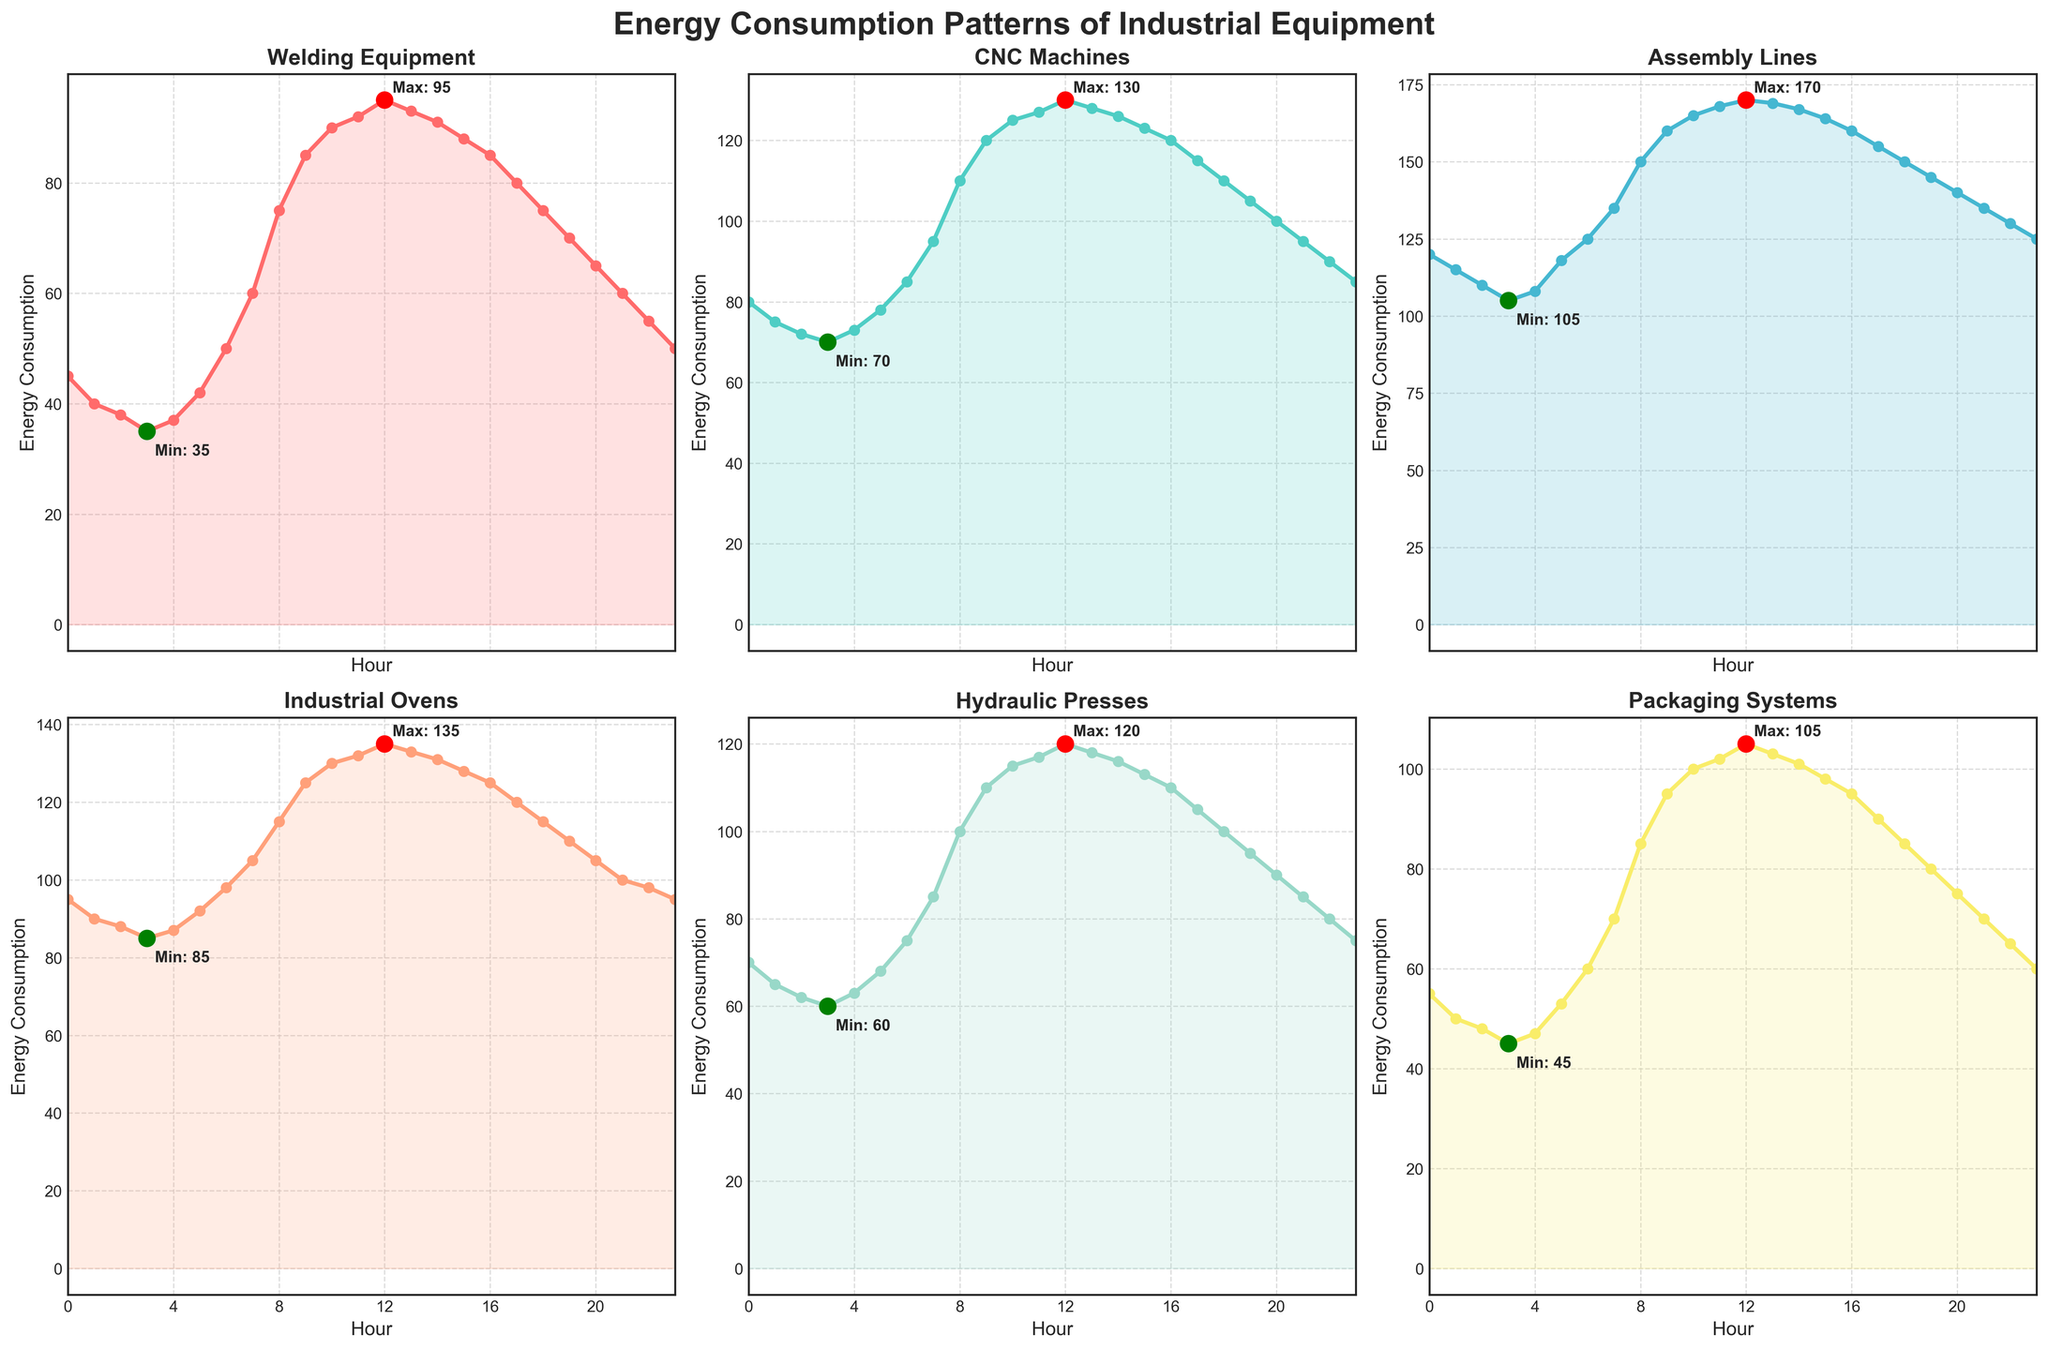What is the maximum energy consumption recorded for Welding Equipment and when does it occur? From the subplot for Welding Equipment, the red highlight indicates the maximum point. Checking the annotated label, the highest value is 95 at hour 12
Answer: 95 at hour 12 Which equipment type consumes the most energy at hour 10? At hour 10, we need to compare the energy consumption across all subplots. Assembly Lines has the tallest peak at this hour with a value of 165
Answer: Assembly Lines How does the energy consumption of CNC Machines compare to Packaging Systems at hour 18? Compare the points at hour 18 in both subplots. CNC Machines have a value of 110, whereas Packaging Systems have 85. Thus, CNC Machines consume more energy
Answer: CNC Machines consume more What is the average energy consumption of Hydraulic Presses from hours 8 to 12? Sum the values from hours 8 to 12 for Hydraulic Presses: (100 + 110 + 115 + 117 + 120) = 562. Then divide by the number of hours, 562/5 = 112.4
Answer: 112.4 Between what hours does the Industrial Ovens' energy consumption consistently stay above 100? Referencing the plot for Industrial Ovens, the energy remains above 100 from hour 9 to 20 consistently
Answer: Hours 9 to 20 Is the minimum energy consumption for Assembly Lines higher or lower than the maximum energy consumption for Welding Equipment? The minimum energy consumption for Assembly Lines is marked in green, which is 105. The maximum for Welding Equipment is 95. Thus, 105 is higher than 95
Answer: Higher What time of day does Hydraulic Presses reach its lowest consumption, and what is the amount? The subplot for Hydraulic Presses shows a green highlight at hour 2. The annotated value is 60
Answer: Hour 2, 60 Compare the energy consumption patterns of Welding Equipment and Industrial Ovens at night (hours 20 to 23). Which equipment shows a greater decrease? At hour 20, Welding Equipment has 65 and ends at 50 by hour 23, decreasing by 15. Industrial Ovens start at 105 and drop to 95, a decrease of 10. Welding Equipment shows a greater decrease
Answer: Welding Equipment What is the difference in energy consumption between CNC Machines and Assembly Lines at their respective peaks? Peak for CNC Machines is 130 at hour 12. Peak for Assembly Lines is 170 at hour 12. The difference is 170 - 130 = 40
Answer: 40 Which equipment types show their maximum energy consumption at the same hour? By examining each subplot's red highlights and labels, CNC Machines, Assembly Lines, Industrial Ovens, and Hydraulic Presses all reach their max at hour 12
Answer: CNC Machines, Assembly Lines, Industrial Ovens, Hydraulic Presses 